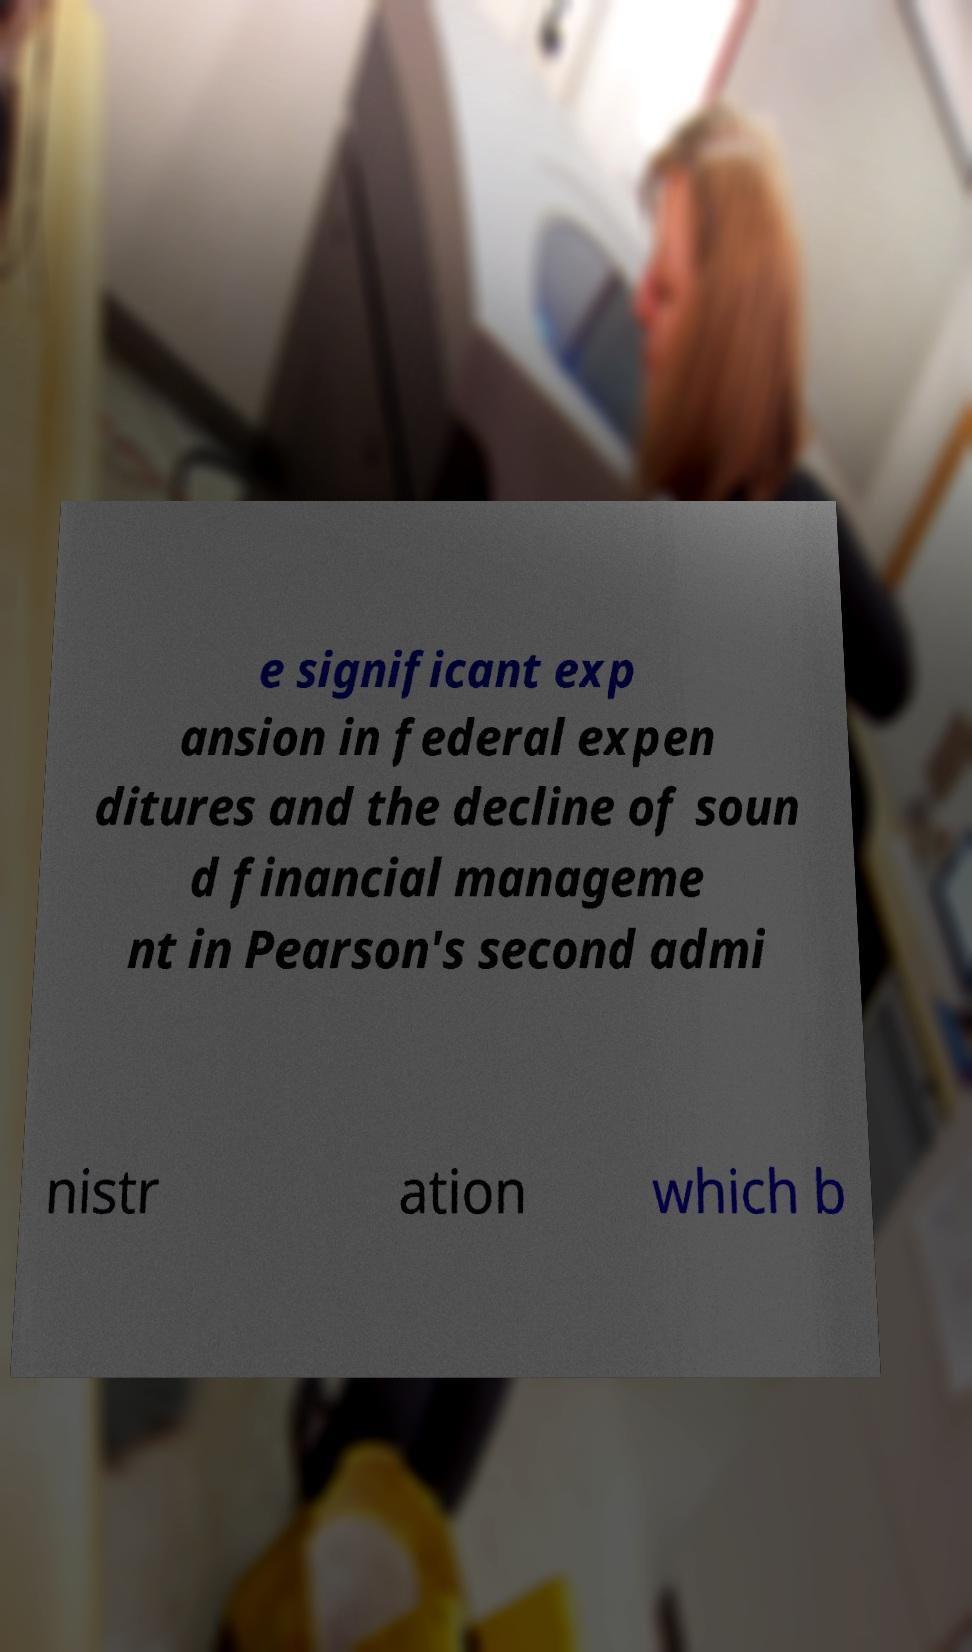For documentation purposes, I need the text within this image transcribed. Could you provide that? e significant exp ansion in federal expen ditures and the decline of soun d financial manageme nt in Pearson's second admi nistr ation which b 